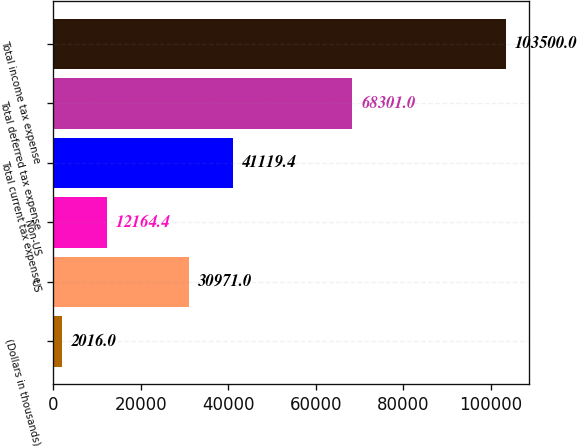<chart> <loc_0><loc_0><loc_500><loc_500><bar_chart><fcel>(Dollars in thousands)<fcel>US<fcel>Non-US<fcel>Total current tax expense<fcel>Total deferred tax expense<fcel>Total income tax expense<nl><fcel>2016<fcel>30971<fcel>12164.4<fcel>41119.4<fcel>68301<fcel>103500<nl></chart> 